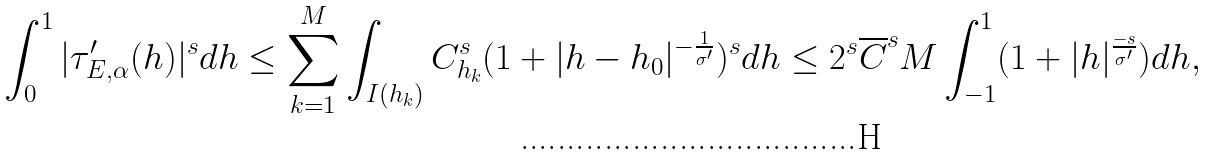Convert formula to latex. <formula><loc_0><loc_0><loc_500><loc_500>\int _ { 0 } ^ { 1 } | \tau _ { E , \alpha } ^ { \prime } ( h ) | ^ { s } d h & \leq \sum _ { k = 1 } ^ { M } \int _ { I ( h _ { k } ) } C _ { h _ { k } } ^ { s } ( 1 + | h - h _ { 0 } | ^ { - \frac { 1 } { \sigma ^ { \prime } } } ) ^ { s } d h \leq 2 ^ { s } \overline { C } ^ { s } M \int _ { - 1 } ^ { 1 } ( 1 + | h | ^ { \frac { - s } { \sigma ^ { \prime } } } ) d h ,</formula> 